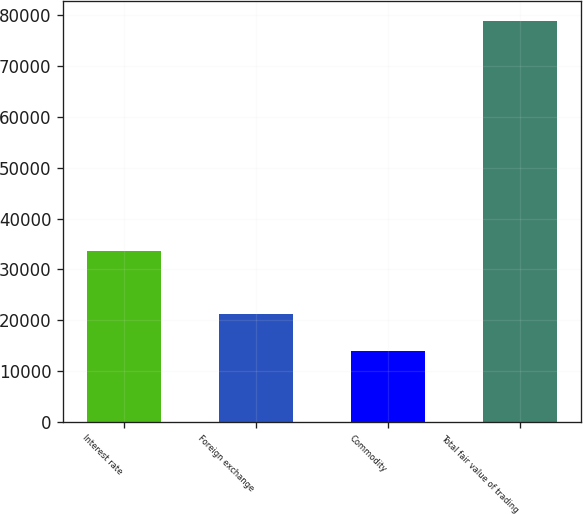<chart> <loc_0><loc_0><loc_500><loc_500><bar_chart><fcel>Interest rate<fcel>Foreign exchange<fcel>Commodity<fcel>Total fair value of trading<nl><fcel>33725<fcel>21253<fcel>13982<fcel>78975<nl></chart> 